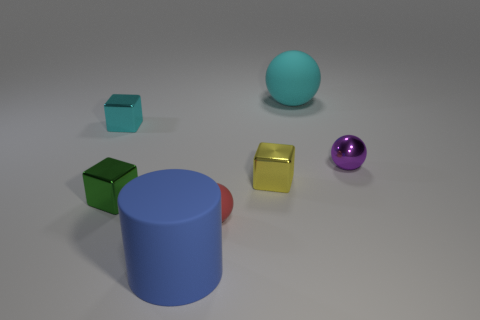How many other things are there of the same color as the big ball?
Keep it short and to the point. 1. How many gray shiny cylinders are there?
Ensure brevity in your answer.  0. How many large things are behind the matte cylinder and to the left of the yellow block?
Give a very brief answer. 0. What is the red ball made of?
Your answer should be very brief. Rubber. Is there a big brown matte object?
Your answer should be compact. No. There is a object in front of the tiny red matte thing; what is its color?
Provide a succinct answer. Blue. There is a rubber cylinder that is in front of the large rubber object right of the red rubber sphere; how many small shiny blocks are behind it?
Provide a short and direct response. 3. What material is the object that is both in front of the green metallic cube and behind the large blue rubber cylinder?
Offer a terse response. Rubber. Are the tiny red object and the tiny ball behind the small yellow shiny thing made of the same material?
Offer a terse response. No. Is the number of cyan matte objects that are in front of the small red matte thing greater than the number of metallic balls behind the purple shiny thing?
Offer a very short reply. No. 